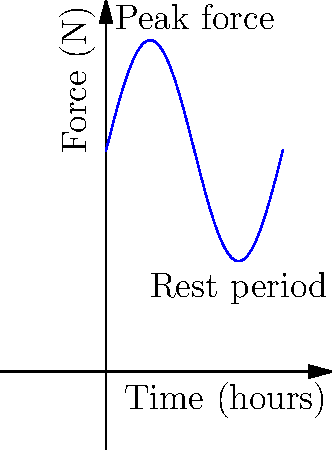In an office environment, repetitive stress injuries often result from prolonged keyboard use. The graph shows the force applied to a worker's fingers during an 8-hour workday. If the worker takes a 15-minute break every 2 hours, what is the total time (in hours) that the worker's fingers are subjected to forces above the average force level? To solve this problem, we need to follow these steps:

1. Determine the average force level:
   The force oscillates between 5N and 15N.
   Average force = $\frac{5N + 15N}{2} = 10N$

2. Identify the periods when force exceeds average:
   The force is above 10N for half of each cycle, which is 2 hours long.

3. Calculate the duration of force above average per cycle:
   Duration = $\frac{1}{2} \times 2$ hours = 1 hour

4. Account for breaks:
   There are 3 breaks of 15 minutes each during the 8-hour workday.
   Total break time = $3 \times 0.25$ hours = 0.75 hours

5. Calculate the total working time:
   Working time = 8 hours - 0.75 hours = 7.25 hours

6. Calculate the number of complete cycles in working time:
   Number of cycles = 7.25 hours ÷ 2 hours/cycle = 3.625 cycles

7. Calculate the total time force is above average:
   Time above average = 3.625 cycles × 1 hour/cycle = 3.625 hours

Therefore, the worker's fingers are subjected to forces above the average force level for 3.625 hours during the workday.
Answer: 3.625 hours 